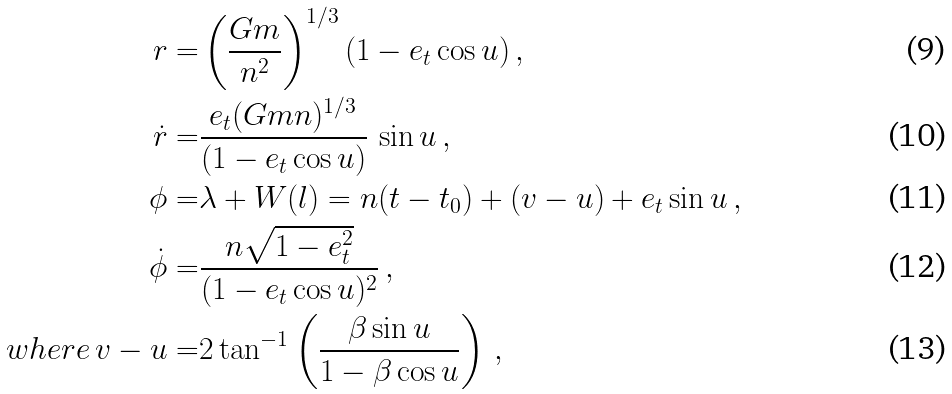<formula> <loc_0><loc_0><loc_500><loc_500>r = & \left ( \frac { G m } { n ^ { 2 } } \right ) ^ { 1 / 3 } ( 1 - e _ { t } \cos u ) \, , \\ \dot { r } = & \frac { e _ { t } ( G m n ) ^ { 1 / 3 } } { ( 1 - e _ { t } \cos u ) } \, \sin u \, , \\ \phi = & \lambda + W ( l ) = n ( t - t _ { 0 } ) + ( v - u ) + e _ { t } \sin u \, , \\ \dot { \phi } = & \frac { n \sqrt { 1 - e _ { t } ^ { 2 } } } { ( 1 - e _ { t } \cos u ) ^ { 2 } } \, , \\ w h e r e \, v - u = & 2 \tan ^ { - 1 } \left ( \frac { \beta \sin u } { 1 - \beta \cos u } \right ) \, ,</formula> 